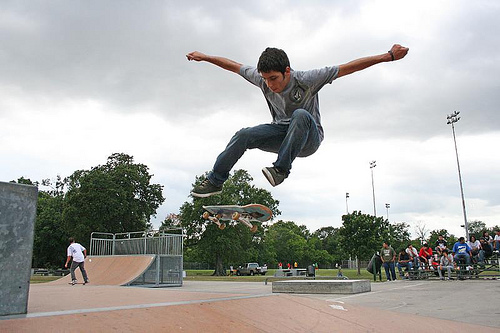<image>
Is the tree behind the man? Yes. From this viewpoint, the tree is positioned behind the man, with the man partially or fully occluding the tree. Is the man above the young man? No. The man is not positioned above the young man. The vertical arrangement shows a different relationship. 